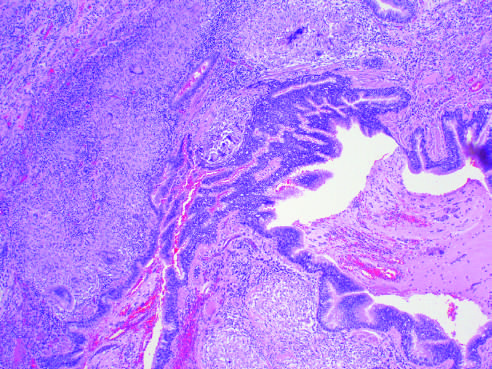re t_h 17 cells in granuloma formation present?
Answer the question using a single word or phrase. No 